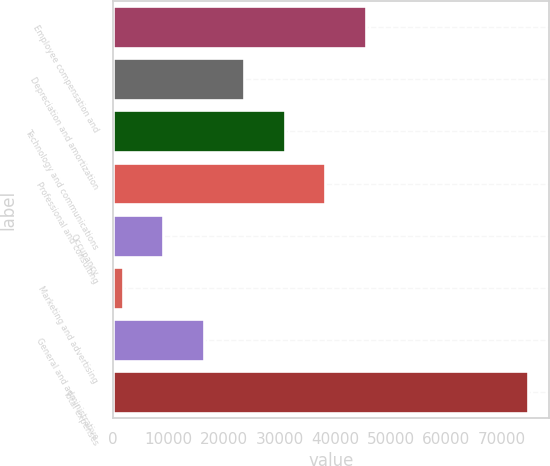<chart> <loc_0><loc_0><loc_500><loc_500><bar_chart><fcel>Employee compensation and<fcel>Depreciation and amortization<fcel>Technology and communications<fcel>Professional and consulting<fcel>Occupancy<fcel>Marketing and advertising<fcel>General and administrative<fcel>Total expenses<nl><fcel>45534.8<fcel>23651.9<fcel>30946.2<fcel>38240.5<fcel>9063.3<fcel>1769<fcel>16357.6<fcel>74712<nl></chart> 